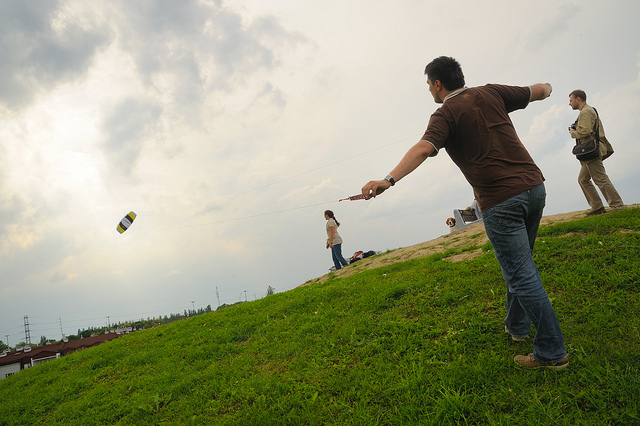How many people are visible? There are three individuals visible in the image, with one person in the foreground engaged in an activity that involves throwing or flying an object, and two more people in the background, one of which appears to be watching the activity. 